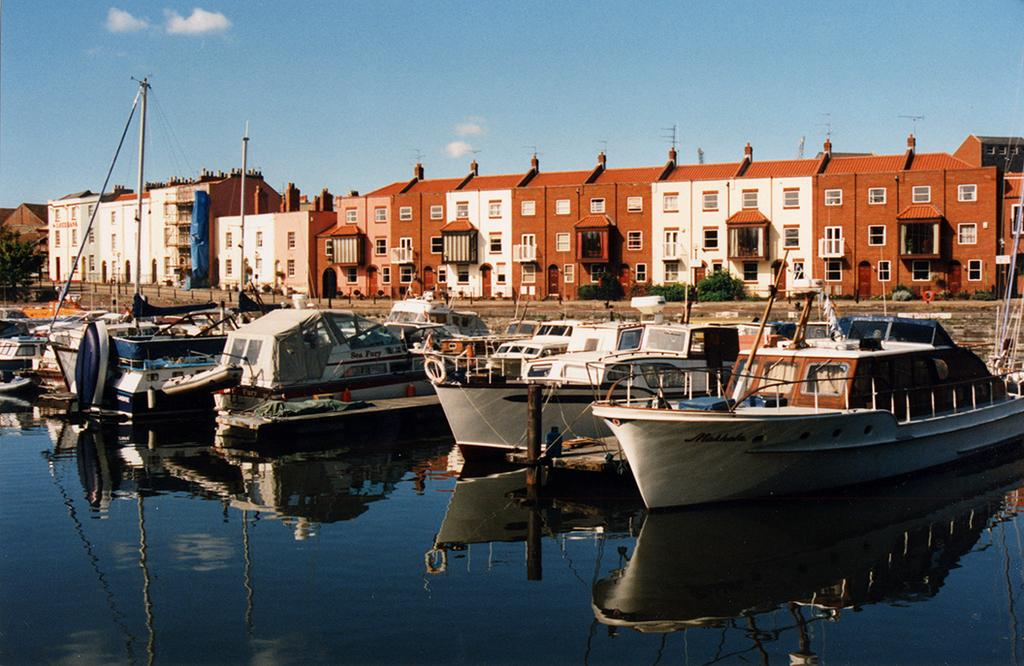What is on the water in the image? There are boats on the water in the image. What structures can be seen in the image besides the boats? There are poles, a tree, plants, buildings, and the sky visible in the image. Can you describe the vegetation in the image? There are plants and a tree in the image. What is visible in the background of the image? The sky is visible in the background of the image. What type of berry is being used to write on the paper in the image? There is no berry or paper present in the image; it features boats on the water, poles, a tree, plants, buildings, and the sky. What is happening on the back of the image? The image does not have a back, as it is a two-dimensional representation. 